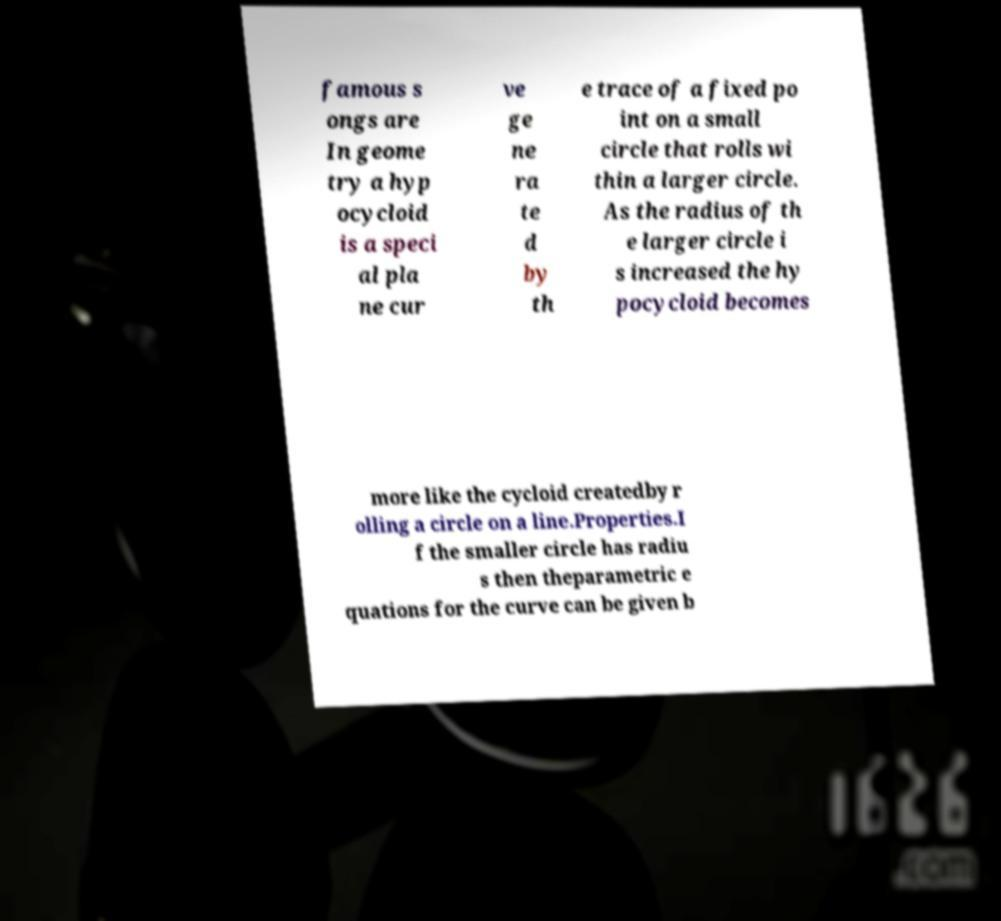I need the written content from this picture converted into text. Can you do that? famous s ongs are In geome try a hyp ocycloid is a speci al pla ne cur ve ge ne ra te d by th e trace of a fixed po int on a small circle that rolls wi thin a larger circle. As the radius of th e larger circle i s increased the hy pocycloid becomes more like the cycloid createdby r olling a circle on a line.Properties.I f the smaller circle has radiu s then theparametric e quations for the curve can be given b 